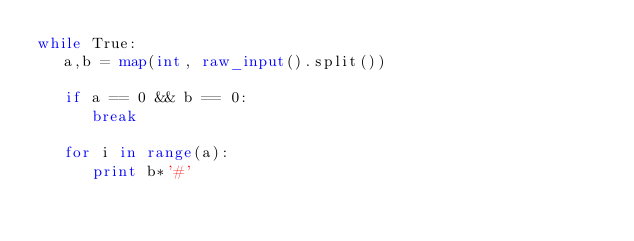Convert code to text. <code><loc_0><loc_0><loc_500><loc_500><_Python_>while True:
   a,b = map(int, raw_input().split())

   if a == 0 && b == 0:
      break
    
   for i in range(a):
      print b*'#'
      </code> 